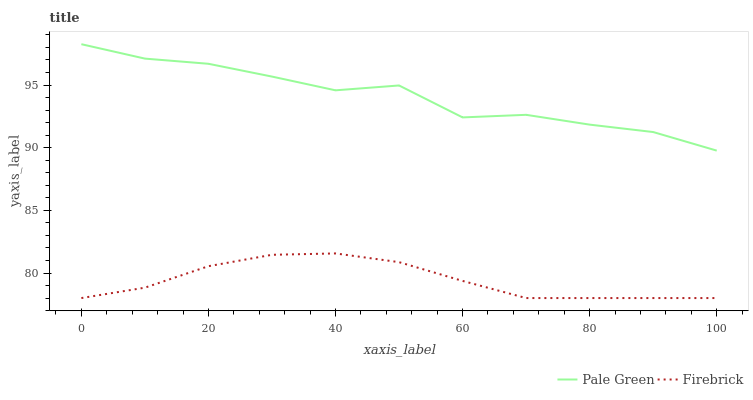Does Firebrick have the minimum area under the curve?
Answer yes or no. Yes. Does Pale Green have the maximum area under the curve?
Answer yes or no. Yes. Does Pale Green have the minimum area under the curve?
Answer yes or no. No. Is Firebrick the smoothest?
Answer yes or no. Yes. Is Pale Green the roughest?
Answer yes or no. Yes. Is Pale Green the smoothest?
Answer yes or no. No. Does Firebrick have the lowest value?
Answer yes or no. Yes. Does Pale Green have the lowest value?
Answer yes or no. No. Does Pale Green have the highest value?
Answer yes or no. Yes. Is Firebrick less than Pale Green?
Answer yes or no. Yes. Is Pale Green greater than Firebrick?
Answer yes or no. Yes. Does Firebrick intersect Pale Green?
Answer yes or no. No. 